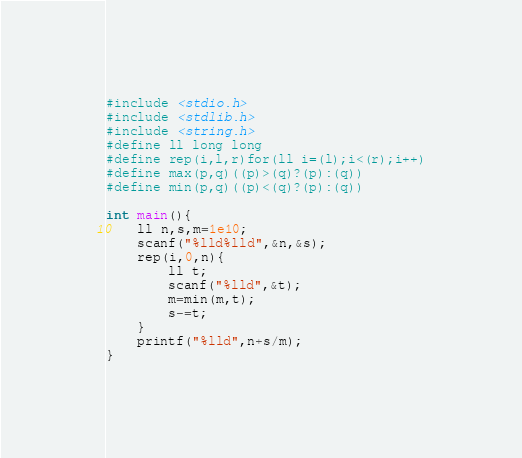<code> <loc_0><loc_0><loc_500><loc_500><_C_>#include <stdio.h>
#include <stdlib.h>
#include <string.h>
#define ll long long
#define rep(i,l,r)for(ll i=(l);i<(r);i++)
#define max(p,q)((p)>(q)?(p):(q))
#define min(p,q)((p)<(q)?(p):(q))

int main(){
	ll n,s,m=1e10;
	scanf("%lld%lld",&n,&s);
	rep(i,0,n){
		ll t;
		scanf("%lld",&t);
		m=min(m,t);
		s-=t;
	}
	printf("%lld",n+s/m);
}</code> 